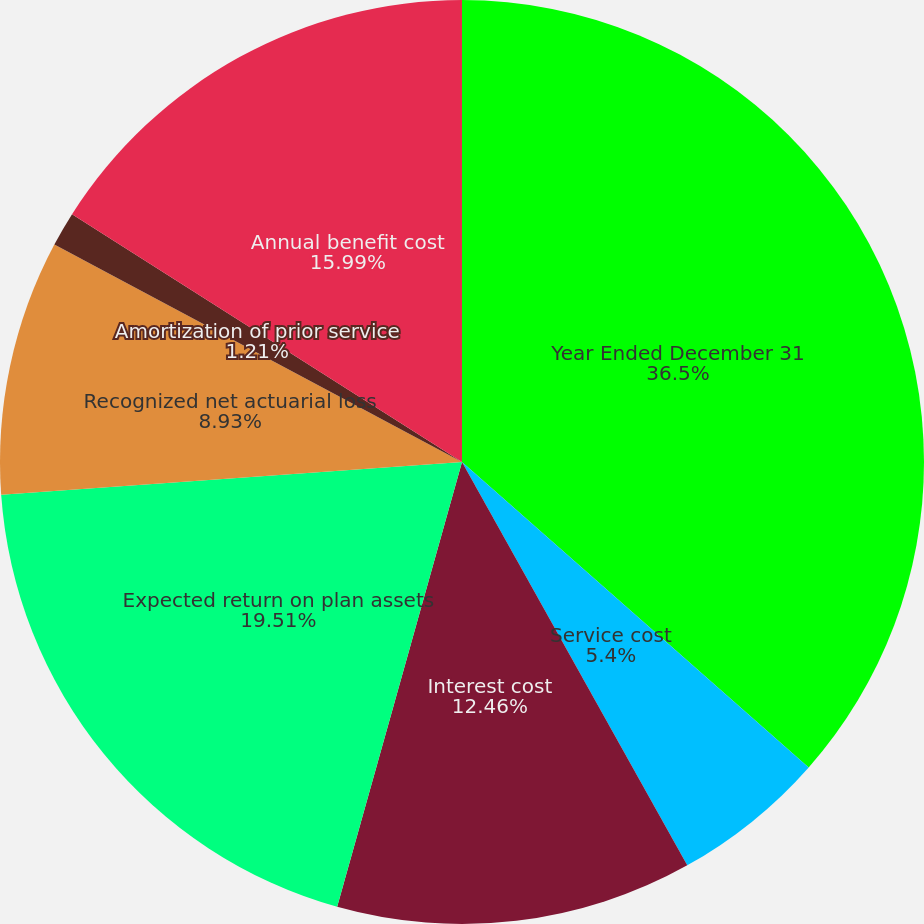Convert chart to OTSL. <chart><loc_0><loc_0><loc_500><loc_500><pie_chart><fcel>Year Ended December 31<fcel>Service cost<fcel>Interest cost<fcel>Expected return on plan assets<fcel>Recognized net actuarial loss<fcel>Amortization of prior service<fcel>Annual benefit cost<nl><fcel>36.49%<fcel>5.4%<fcel>12.46%<fcel>19.51%<fcel>8.93%<fcel>1.21%<fcel>15.99%<nl></chart> 